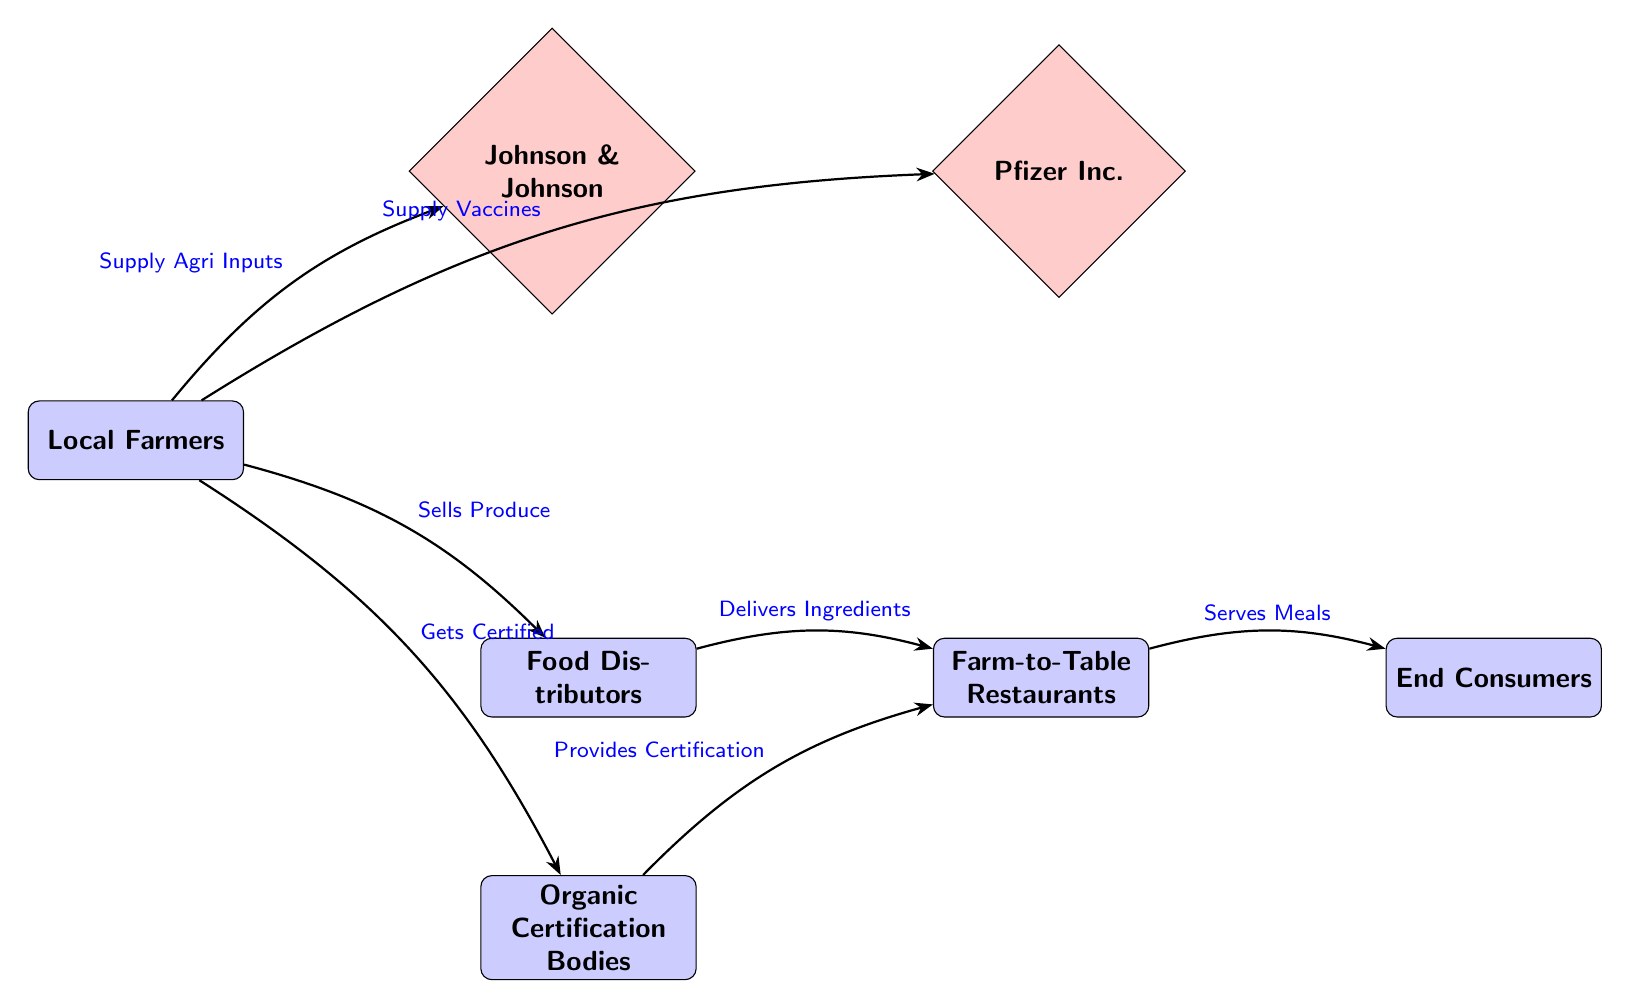What are the two pharmaceutical companies shown in the diagram? The diagram features two pharmaceutical companies represented by the nodes: Johnson & Johnson and Pfizer Inc.
Answer: Johnson & Johnson, Pfizer Inc How many stakeholders are involved in the farm-to-table initiative shown in the diagram? There are four stakeholder nodes illustrated in the diagram: Local Farmers, Food Distributors, Farm-to-Table Restaurants, and End Consumers.
Answer: Four What does the arrow from Local Farmers to Johnson & Johnson represent? The arrow indicates the supply relationship, specifically that Local Farmers provide agricultural inputs to Johnson & Johnson, which is a pharmaceutical company.
Answer: Supply Agri Inputs How does the Food Distributor interact with the Restaurant? The Food Distributor delivers ingredients to the Farm-to-Table Restaurants, as shown by the arrow connecting these two nodes.
Answer: Delivers Ingredients What certification process is depicted in the diagram? Local Farmers get certified by Organic Certification Bodies, as indicated by the arrow pointing from Local Farmers to the certification body, which then provides certification to Restaurants.
Answer: Gets Certified, Provides Certification Which entity serves meals to End Consumers according to the diagram? The Farm-to-Table Restaurants serve meals to the End Consumers, as indicated by the directional arrow from the restaurant to the consumer.
Answer: Serves Meals What inputs do Local Farmers supply to Pfizer Inc.? Local Farmers supply vaccines to Pfizer Inc., represented by the specific connection in the diagram.
Answer: Supply Vaccines What is the role of Organic Certification Bodies in the initiative? Organic Certification Bodies provide certification to Restaurants, indicating the quality and standards of the products sourced from Local Farmers. This is shown as a two-part flow from Local Farmers to the certification body, and then from the certification body to the Restaurants.
Answer: Provides Certification How many arrows are there indicating relationships in the diagram? Counting all the directed arrows, we find six arrows that represent relationships between different stakeholders and pharmaceutical companies in the diagram.
Answer: Six 